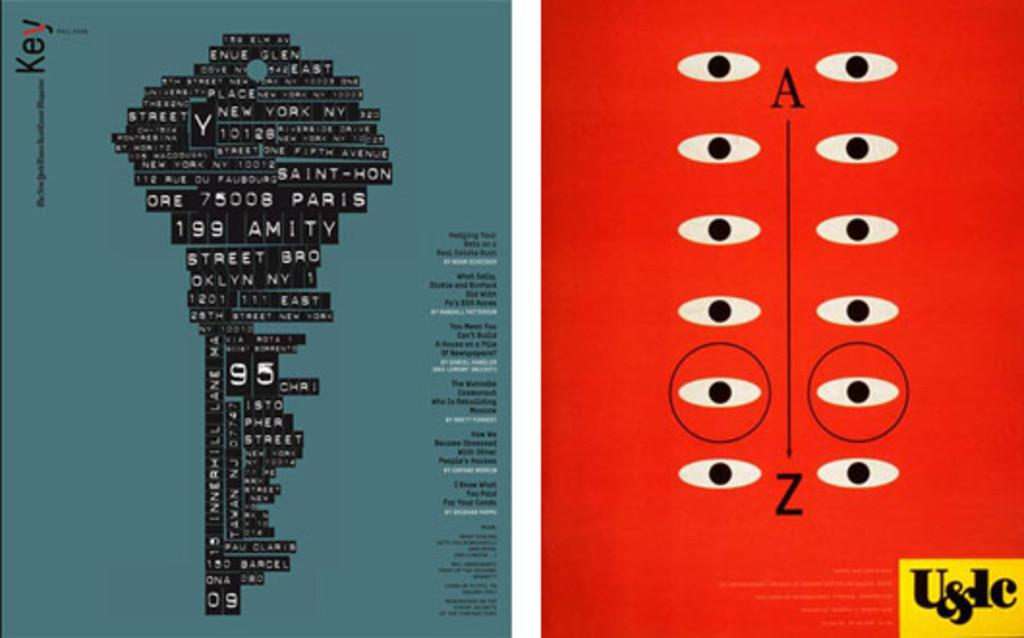<image>
Create a compact narrative representing the image presented. a program for Key with a red side that says A-Z 